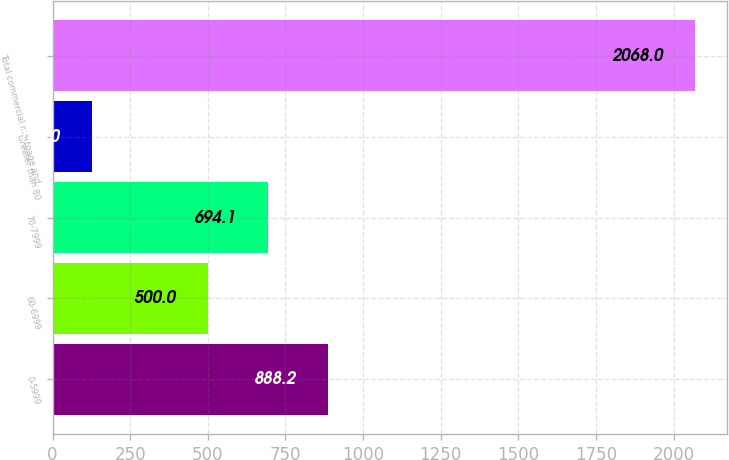Convert chart. <chart><loc_0><loc_0><loc_500><loc_500><bar_chart><fcel>0-5999<fcel>60-6999<fcel>70-7999<fcel>Greater than 80<fcel>Total commercial mortgage and<nl><fcel>888.2<fcel>500<fcel>694.1<fcel>127<fcel>2068<nl></chart> 